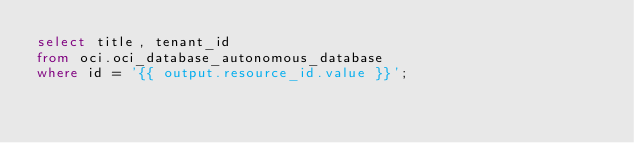<code> <loc_0><loc_0><loc_500><loc_500><_SQL_>select title, tenant_id
from oci.oci_database_autonomous_database
where id = '{{ output.resource_id.value }}';</code> 